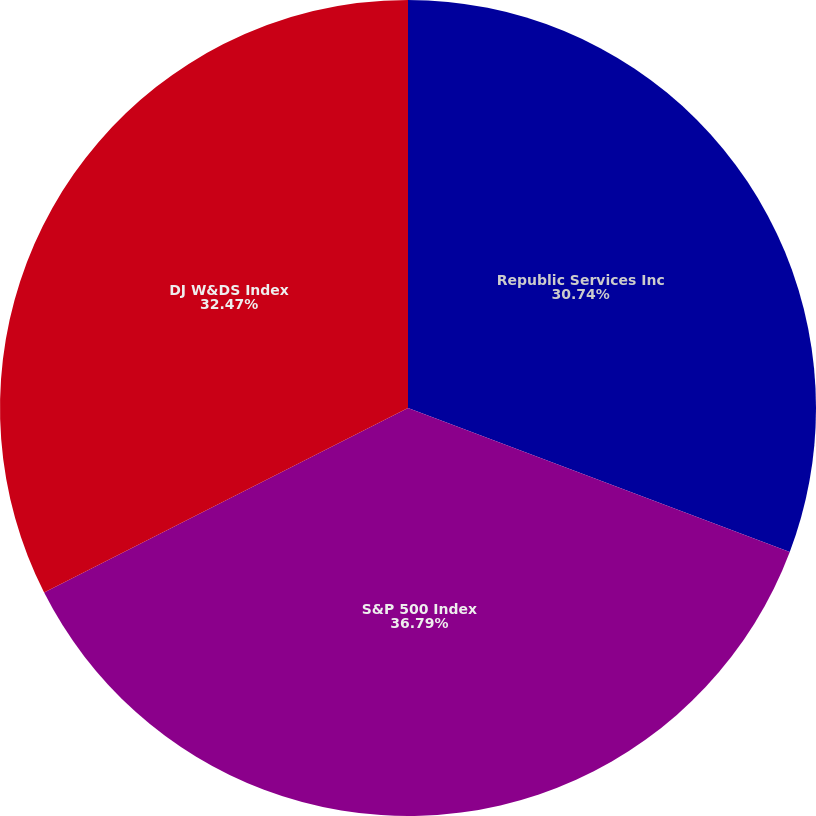Convert chart to OTSL. <chart><loc_0><loc_0><loc_500><loc_500><pie_chart><fcel>Republic Services Inc<fcel>S&P 500 Index<fcel>DJ W&DS Index<nl><fcel>30.74%<fcel>36.79%<fcel>32.47%<nl></chart> 